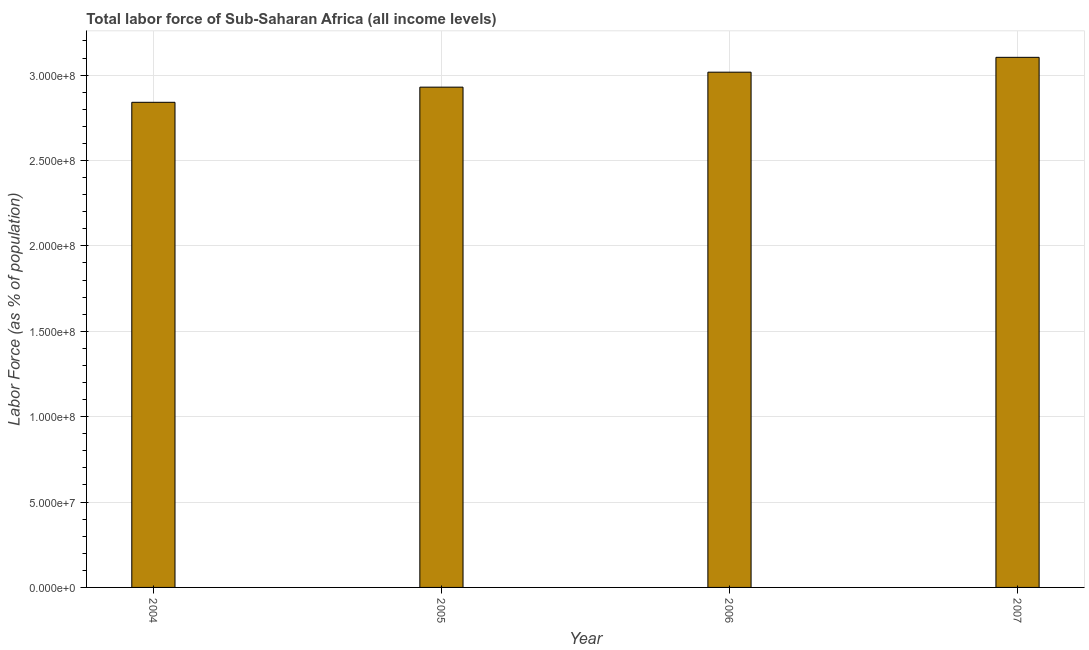What is the title of the graph?
Offer a terse response. Total labor force of Sub-Saharan Africa (all income levels). What is the label or title of the Y-axis?
Make the answer very short. Labor Force (as % of population). What is the total labor force in 2004?
Give a very brief answer. 2.84e+08. Across all years, what is the maximum total labor force?
Ensure brevity in your answer.  3.10e+08. Across all years, what is the minimum total labor force?
Offer a very short reply. 2.84e+08. In which year was the total labor force maximum?
Your answer should be very brief. 2007. What is the sum of the total labor force?
Ensure brevity in your answer.  1.19e+09. What is the difference between the total labor force in 2004 and 2005?
Make the answer very short. -8.88e+06. What is the average total labor force per year?
Give a very brief answer. 2.97e+08. What is the median total labor force?
Your answer should be compact. 2.97e+08. In how many years, is the total labor force greater than 270000000 %?
Ensure brevity in your answer.  4. What is the ratio of the total labor force in 2004 to that in 2005?
Give a very brief answer. 0.97. Is the difference between the total labor force in 2004 and 2006 greater than the difference between any two years?
Provide a succinct answer. No. What is the difference between the highest and the second highest total labor force?
Your response must be concise. 8.70e+06. What is the difference between the highest and the lowest total labor force?
Provide a short and direct response. 2.63e+07. In how many years, is the total labor force greater than the average total labor force taken over all years?
Provide a succinct answer. 2. What is the Labor Force (as % of population) of 2004?
Keep it short and to the point. 2.84e+08. What is the Labor Force (as % of population) of 2005?
Offer a very short reply. 2.93e+08. What is the Labor Force (as % of population) of 2006?
Your answer should be very brief. 3.02e+08. What is the Labor Force (as % of population) of 2007?
Offer a terse response. 3.10e+08. What is the difference between the Labor Force (as % of population) in 2004 and 2005?
Offer a very short reply. -8.88e+06. What is the difference between the Labor Force (as % of population) in 2004 and 2006?
Offer a very short reply. -1.76e+07. What is the difference between the Labor Force (as % of population) in 2004 and 2007?
Ensure brevity in your answer.  -2.63e+07. What is the difference between the Labor Force (as % of population) in 2005 and 2006?
Your response must be concise. -8.76e+06. What is the difference between the Labor Force (as % of population) in 2005 and 2007?
Your response must be concise. -1.75e+07. What is the difference between the Labor Force (as % of population) in 2006 and 2007?
Provide a succinct answer. -8.70e+06. What is the ratio of the Labor Force (as % of population) in 2004 to that in 2006?
Your answer should be compact. 0.94. What is the ratio of the Labor Force (as % of population) in 2004 to that in 2007?
Provide a short and direct response. 0.92. What is the ratio of the Labor Force (as % of population) in 2005 to that in 2006?
Your response must be concise. 0.97. What is the ratio of the Labor Force (as % of population) in 2005 to that in 2007?
Your answer should be very brief. 0.94. 